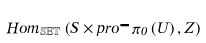Convert formula to latex. <formula><loc_0><loc_0><loc_500><loc_500>H o m _ { \mathbb { S E T } } \left ( S \times p r o \text {-} \pi _ { 0 } \left ( U \right ) , Z \right )</formula> 